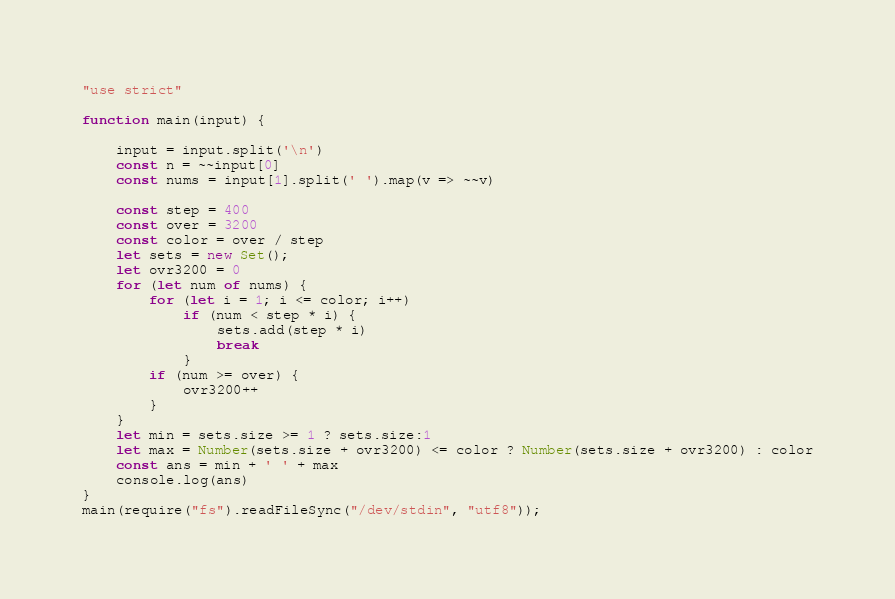Convert code to text. <code><loc_0><loc_0><loc_500><loc_500><_JavaScript_>"use strict"

function main(input) {

    input = input.split('\n')
    const n = ~~input[0]
    const nums = input[1].split(' ').map(v => ~~v)

    const step = 400
    const over = 3200
    const color = over / step
    let sets = new Set();
    let ovr3200 = 0
    for (let num of nums) {
        for (let i = 1; i <= color; i++)
            if (num < step * i) {
                sets.add(step * i)
                break
            }
        if (num >= over) {
            ovr3200++
        }
    }
    let min = sets.size >= 1 ? sets.size:1 
    let max = Number(sets.size + ovr3200) <= color ? Number(sets.size + ovr3200) : color
    const ans = min + ' ' + max 
    console.log(ans)
}
main(require("fs").readFileSync("/dev/stdin", "utf8"));</code> 